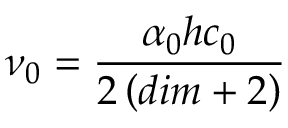<formula> <loc_0><loc_0><loc_500><loc_500>\nu _ { 0 } = \frac { \alpha _ { 0 } h c _ { 0 } } { 2 \left ( d i m + 2 \right ) }</formula> 